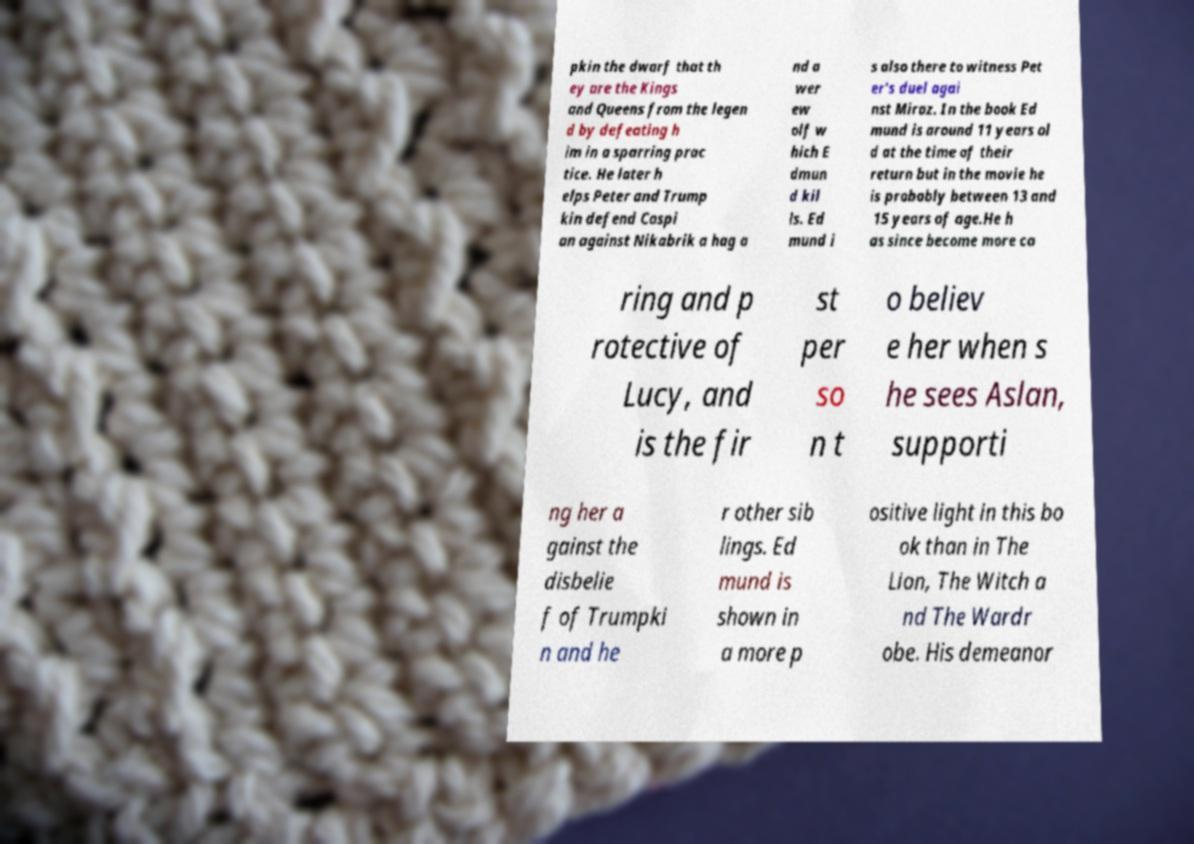Can you accurately transcribe the text from the provided image for me? pkin the dwarf that th ey are the Kings and Queens from the legen d by defeating h im in a sparring prac tice. He later h elps Peter and Trump kin defend Caspi an against Nikabrik a hag a nd a wer ew olf w hich E dmun d kil ls. Ed mund i s also there to witness Pet er's duel agai nst Miraz. In the book Ed mund is around 11 years ol d at the time of their return but in the movie he is probably between 13 and 15 years of age.He h as since become more ca ring and p rotective of Lucy, and is the fir st per so n t o believ e her when s he sees Aslan, supporti ng her a gainst the disbelie f of Trumpki n and he r other sib lings. Ed mund is shown in a more p ositive light in this bo ok than in The Lion, The Witch a nd The Wardr obe. His demeanor 